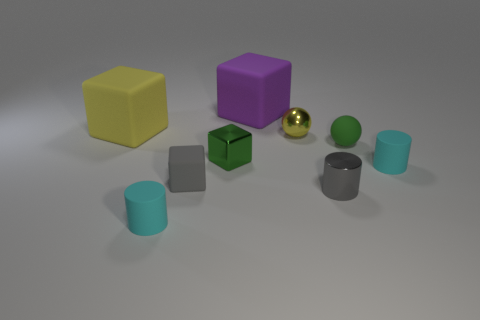What might be the significance of the arrangement of these objects? The objects are placed with ample space between them on a flat surface, suggesting a deliberate arrangement for display or perhaps for a comparative study of their shapes, sizes, and materials. Could they be used for an educational purpose? Indeed, their varied shapes, colors, and materials make these objects suitable for educational demonstrations, such as teaching about geometry, material properties, or color theory. 